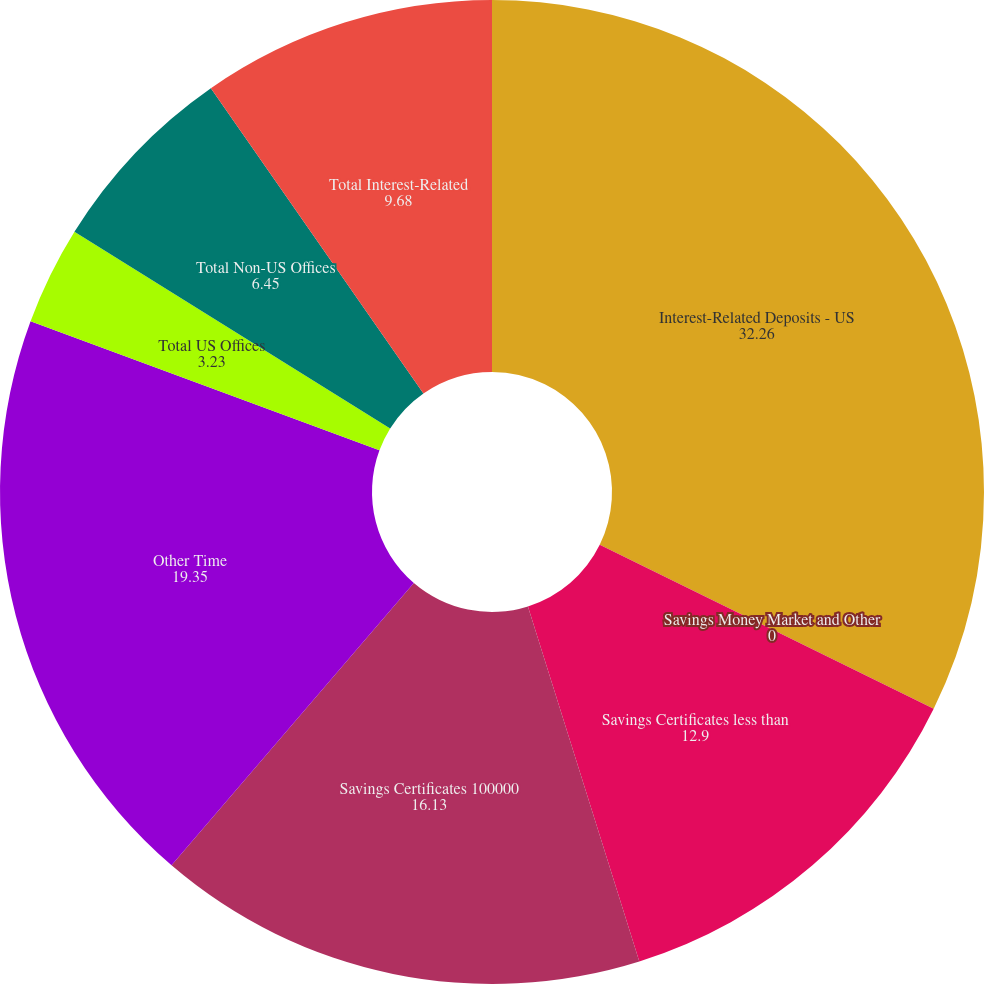Convert chart to OTSL. <chart><loc_0><loc_0><loc_500><loc_500><pie_chart><fcel>Interest-Related Deposits - US<fcel>Savings Money Market and Other<fcel>Savings Certificates less than<fcel>Savings Certificates 100000<fcel>Other Time<fcel>Total US Offices<fcel>Total Non-US Offices<fcel>Total Interest-Related<nl><fcel>32.26%<fcel>0.0%<fcel>12.9%<fcel>16.13%<fcel>19.35%<fcel>3.23%<fcel>6.45%<fcel>9.68%<nl></chart> 